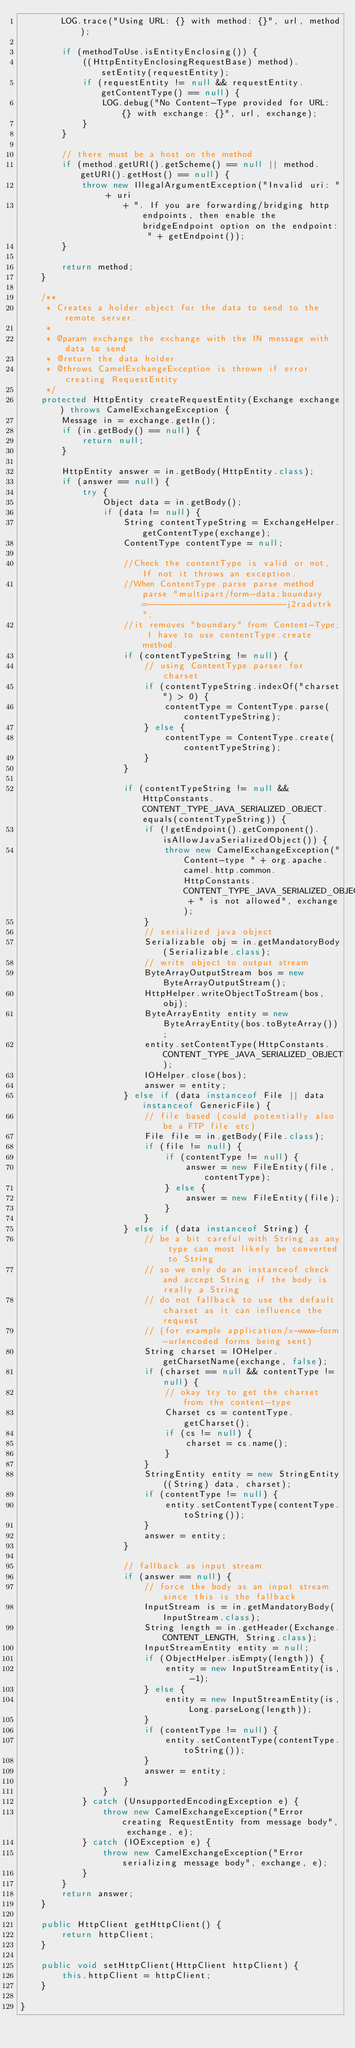Convert code to text. <code><loc_0><loc_0><loc_500><loc_500><_Java_>        LOG.trace("Using URL: {} with method: {}", url, method);

        if (methodToUse.isEntityEnclosing()) {
            ((HttpEntityEnclosingRequestBase) method).setEntity(requestEntity);
            if (requestEntity != null && requestEntity.getContentType() == null) {
                LOG.debug("No Content-Type provided for URL: {} with exchange: {}", url, exchange);
            }
        }

        // there must be a host on the method
        if (method.getURI().getScheme() == null || method.getURI().getHost() == null) {
            throw new IllegalArgumentException("Invalid uri: " + uri
                    + ". If you are forwarding/bridging http endpoints, then enable the bridgeEndpoint option on the endpoint: " + getEndpoint());
        }

        return method;
    }

    /**
     * Creates a holder object for the data to send to the remote server.
     *
     * @param exchange the exchange with the IN message with data to send
     * @return the data holder
     * @throws CamelExchangeException is thrown if error creating RequestEntity
     */
    protected HttpEntity createRequestEntity(Exchange exchange) throws CamelExchangeException {
        Message in = exchange.getIn();
        if (in.getBody() == null) {
            return null;
        }

        HttpEntity answer = in.getBody(HttpEntity.class);
        if (answer == null) {
            try {
                Object data = in.getBody();
                if (data != null) {
                    String contentTypeString = ExchangeHelper.getContentType(exchange);
                    ContentType contentType = null;

                    //Check the contentType is valid or not, If not it throws an exception.
                    //When ContentType.parse parse method parse "multipart/form-data;boundary=---------------------------j2radvtrk",
                    //it removes "boundary" from Content-Type; I have to use contentType.create method.
                    if (contentTypeString != null) {
                        // using ContentType.parser for charset
                        if (contentTypeString.indexOf("charset") > 0) {
                            contentType = ContentType.parse(contentTypeString);
                        } else {
                            contentType = ContentType.create(contentTypeString);
                        }
                    }

                    if (contentTypeString != null && HttpConstants.CONTENT_TYPE_JAVA_SERIALIZED_OBJECT.equals(contentTypeString)) {
                        if (!getEndpoint().getComponent().isAllowJavaSerializedObject()) {
                            throw new CamelExchangeException("Content-type " + org.apache.camel.http.common.HttpConstants.CONTENT_TYPE_JAVA_SERIALIZED_OBJECT + " is not allowed", exchange);
                        }
                        // serialized java object
                        Serializable obj = in.getMandatoryBody(Serializable.class);
                        // write object to output stream
                        ByteArrayOutputStream bos = new ByteArrayOutputStream();
                        HttpHelper.writeObjectToStream(bos, obj);
                        ByteArrayEntity entity = new ByteArrayEntity(bos.toByteArray());
                        entity.setContentType(HttpConstants.CONTENT_TYPE_JAVA_SERIALIZED_OBJECT);
                        IOHelper.close(bos);
                        answer = entity;
                    } else if (data instanceof File || data instanceof GenericFile) {
                        // file based (could potentially also be a FTP file etc)
                        File file = in.getBody(File.class);
                        if (file != null) {
                            if (contentType != null) {
                                answer = new FileEntity(file, contentType);
                            } else {
                                answer = new FileEntity(file);
                            }
                        }
                    } else if (data instanceof String) {
                        // be a bit careful with String as any type can most likely be converted to String
                        // so we only do an instanceof check and accept String if the body is really a String
                        // do not fallback to use the default charset as it can influence the request
                        // (for example application/x-www-form-urlencoded forms being sent)
                        String charset = IOHelper.getCharsetName(exchange, false);
                        if (charset == null && contentType != null) {
                            // okay try to get the charset from the content-type
                            Charset cs = contentType.getCharset();
                            if (cs != null) {
                                charset = cs.name();
                            }
                        }
                        StringEntity entity = new StringEntity((String) data, charset);
                        if (contentType != null) {
                            entity.setContentType(contentType.toString());
                        }
                        answer = entity;
                    }

                    // fallback as input stream
                    if (answer == null) {
                        // force the body as an input stream since this is the fallback
                        InputStream is = in.getMandatoryBody(InputStream.class);
                        String length = in.getHeader(Exchange.CONTENT_LENGTH, String.class);
                        InputStreamEntity entity = null;
                        if (ObjectHelper.isEmpty(length)) {
                            entity = new InputStreamEntity(is, -1);
                        } else {
                            entity = new InputStreamEntity(is, Long.parseLong(length));
                        }
                        if (contentType != null) {
                            entity.setContentType(contentType.toString());
                        }
                        answer = entity;
                    }
                }
            } catch (UnsupportedEncodingException e) {
                throw new CamelExchangeException("Error creating RequestEntity from message body", exchange, e);
            } catch (IOException e) {
                throw new CamelExchangeException("Error serializing message body", exchange, e);
            }
        }
        return answer;
    }

    public HttpClient getHttpClient() {
        return httpClient;
    }

    public void setHttpClient(HttpClient httpClient) {
        this.httpClient = httpClient;
    }

}
</code> 